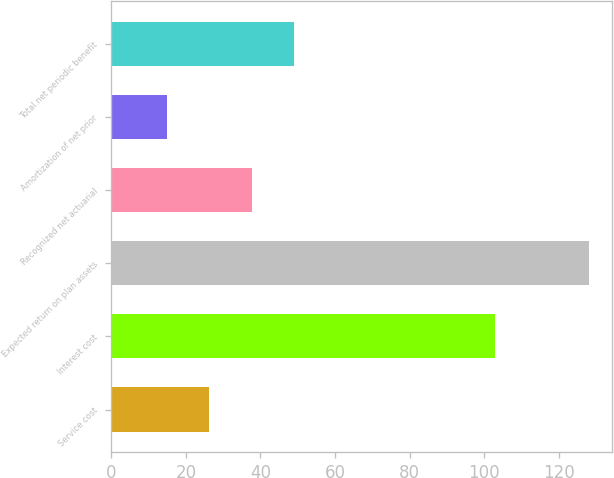<chart> <loc_0><loc_0><loc_500><loc_500><bar_chart><fcel>Service cost<fcel>Interest cost<fcel>Expected return on plan assets<fcel>Recognized net actuarial<fcel>Amortization of net prior<fcel>Total net periodic benefit<nl><fcel>26.3<fcel>103<fcel>128<fcel>37.6<fcel>15<fcel>48.9<nl></chart> 